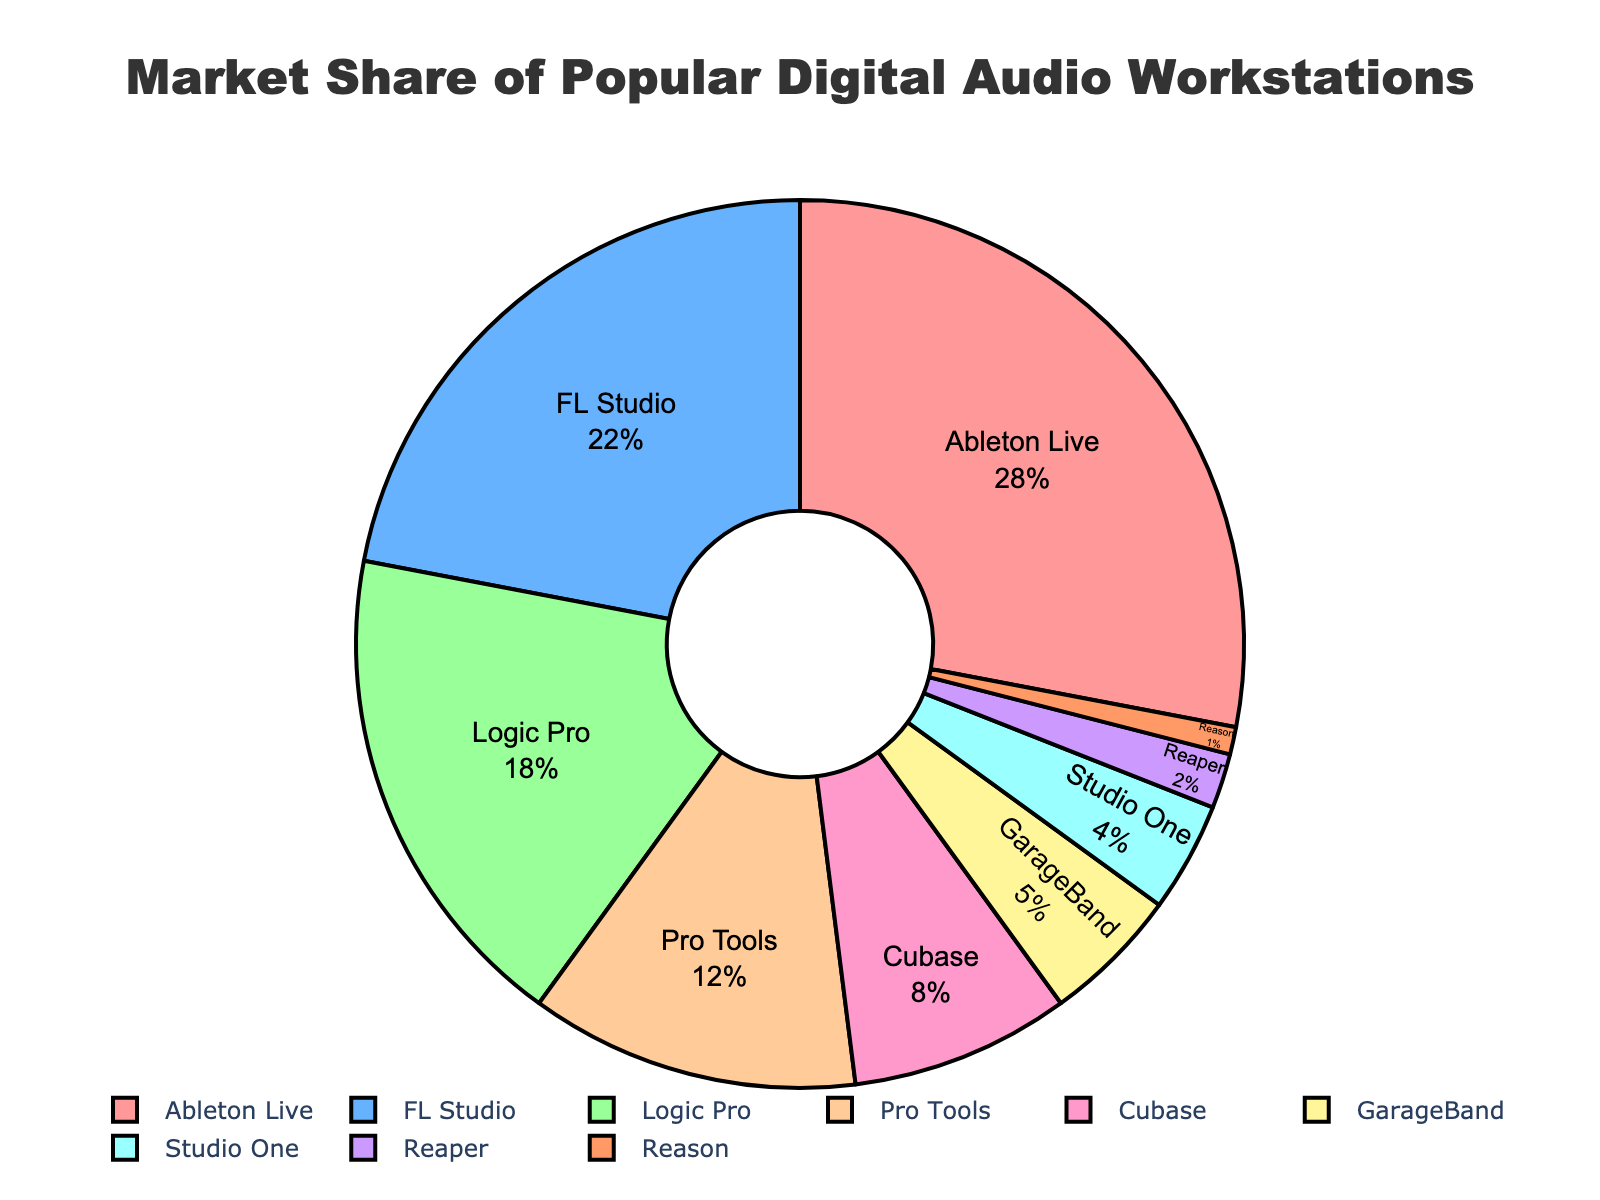what is the combined market share of Ableton Live and FL Studio? First, identify the market share of Ableton Live as 28% and FL Studio as 22%. Adding them together, 28 + 22 = 50
Answer: 50% which DAW holds the smallest market share? Identify the DAW with the smallest segment in the pie chart, which is Reason at 1%
Answer: Reason what is the difference in market share between Logic Pro and GarageBand? Identify the market share of Logic Pro as 18% and GarageBand as 5%. Subtract 5 from 18, resulting in 18 - 5 = 13
Answer: 13% which DAW has a larger market share, Cubase or Pro Tools? Identify the market share of Cubase as 8% and Pro Tools as 12%. Pro Tools has a larger market share compared to Cubase
Answer: Pro Tools what is the color of the segment representing FL Studio? Identify the segment corresponding to FL Studio and note its color, which is blue
Answer: blue between Ableton Live, FL Studio, and Logic Pro, which DAW has the smallest market share? Compare the market shares: Ableton Live at 28%, FL Studio at 22%, and Logic Pro at 18%. Logic Pro has the smallest among these three
Answer: Logic Pro if you combine the market shares of Studio One and Reaper, does it exceed the market share of Cubase? Identify the market shares: Studio One at 4%, Reaper at 2%, and Cubase at 8%. Combined, 4 + 2 = 6, which does not exceed Cubase’s 8%
Answer: No how much greater is the market share of Ableton Live compared to the combined share of Reaper and Reason? Identify Ableton Live's share as 28%, Reaper as 2%, and Reason as 1%. Combined Reaper and Reason is 2 + 1 = 3. The difference is 28 - 3 = 25
Answer: 25% which DAWs have a market share greater than 10%? Identify the DAWs with segments exceeding 10%: Ableton Live (28%), FL Studio (22%), Logic Pro (18%), and Pro Tools (12%)
Answer: Ableton Live, FL Studio, Logic Pro, Pro Tools if a new DAW enters the market and captures 10% share, which DAWs will now have a smaller market share? Compare the new market share of 10% with the current ones. DAWs with market shares smaller than 10%: Cubase (8%), GarageBand (5%), Studio One (4%), Reaper (2%), Reason (1%)
Answer: Cubase, GarageBand, Studio One, Reaper, Reason 